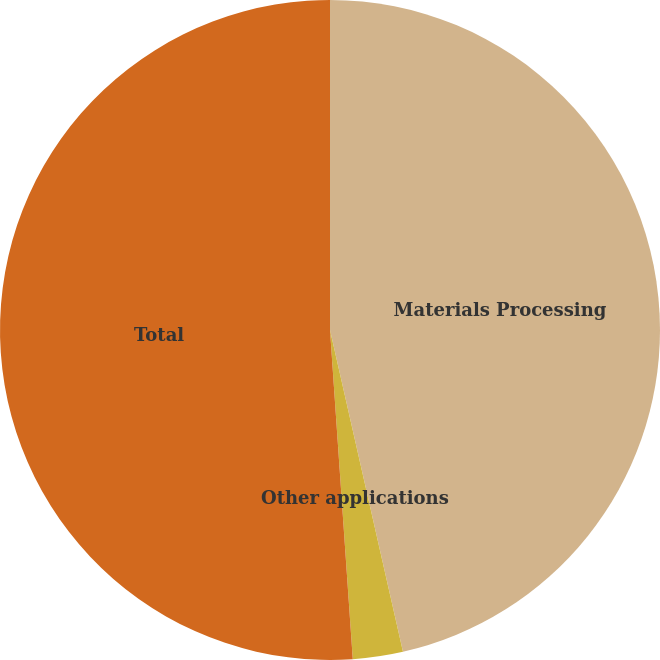Convert chart. <chart><loc_0><loc_0><loc_500><loc_500><pie_chart><fcel>Materials Processing<fcel>Other applications<fcel>Total<nl><fcel>46.45%<fcel>2.45%<fcel>51.1%<nl></chart> 